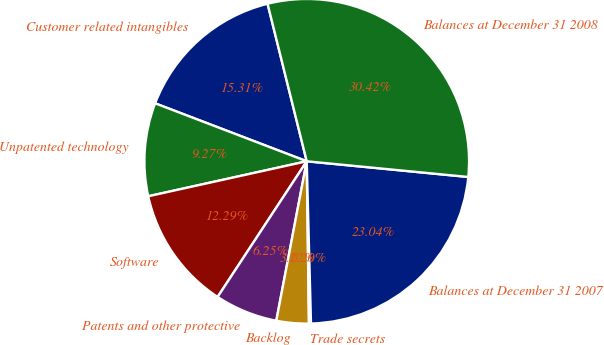Convert chart to OTSL. <chart><loc_0><loc_0><loc_500><loc_500><pie_chart><fcel>Customer related intangibles<fcel>Unpatented technology<fcel>Software<fcel>Patents and other protective<fcel>Backlog<fcel>Trade secrets<fcel>Balances at December 31 2007<fcel>Balances at December 31 2008<nl><fcel>15.31%<fcel>9.27%<fcel>12.29%<fcel>6.25%<fcel>3.22%<fcel>0.2%<fcel>23.04%<fcel>30.42%<nl></chart> 